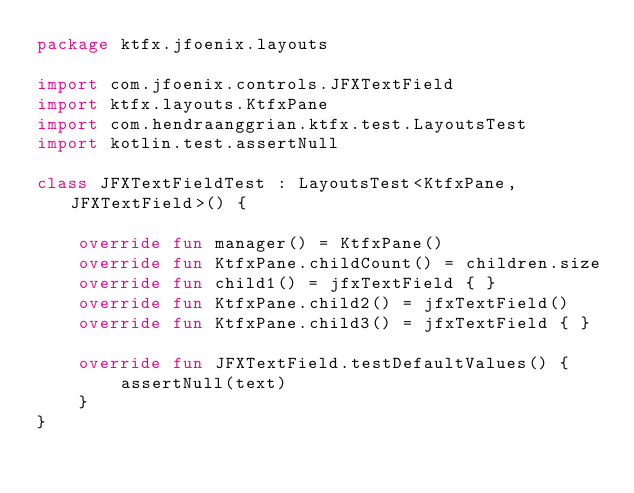<code> <loc_0><loc_0><loc_500><loc_500><_Kotlin_>package ktfx.jfoenix.layouts

import com.jfoenix.controls.JFXTextField
import ktfx.layouts.KtfxPane
import com.hendraanggrian.ktfx.test.LayoutsTest
import kotlin.test.assertNull

class JFXTextFieldTest : LayoutsTest<KtfxPane, JFXTextField>() {

    override fun manager() = KtfxPane()
    override fun KtfxPane.childCount() = children.size
    override fun child1() = jfxTextField { }
    override fun KtfxPane.child2() = jfxTextField()
    override fun KtfxPane.child3() = jfxTextField { }

    override fun JFXTextField.testDefaultValues() {
        assertNull(text)
    }
}</code> 